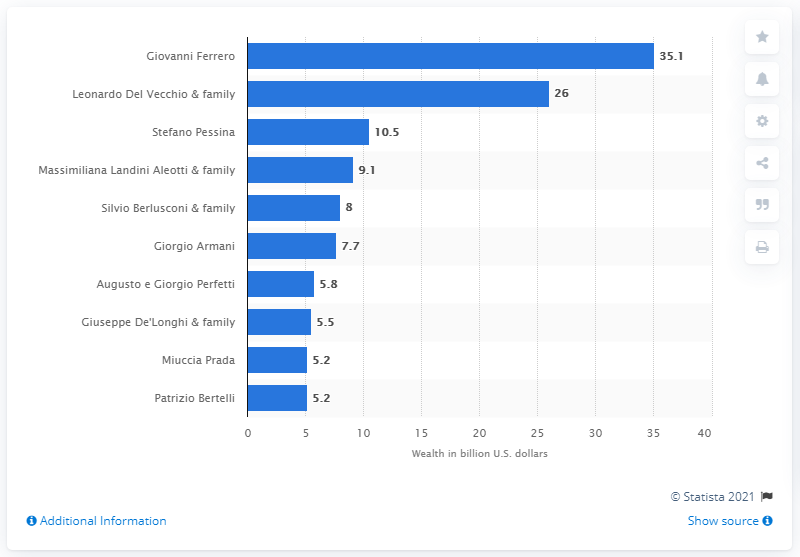Mention a couple of crucial points in this snapshot. In US dollars, Giovanni Ferrero's net worth was 35.1 million as of 2021. How much was Del Vecchio's fortune? 26 million dollars. 